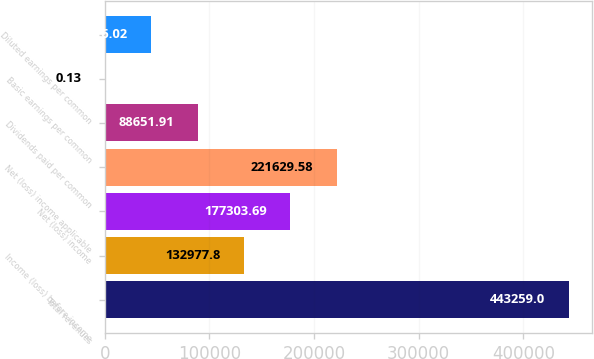Convert chart. <chart><loc_0><loc_0><loc_500><loc_500><bar_chart><fcel>Total revenues<fcel>Income (loss) before income<fcel>Net (loss) income<fcel>Net (loss) income applicable<fcel>Dividends paid per common<fcel>Basic earnings per common<fcel>Diluted earnings per common<nl><fcel>443259<fcel>132978<fcel>177304<fcel>221630<fcel>88651.9<fcel>0.13<fcel>44326<nl></chart> 